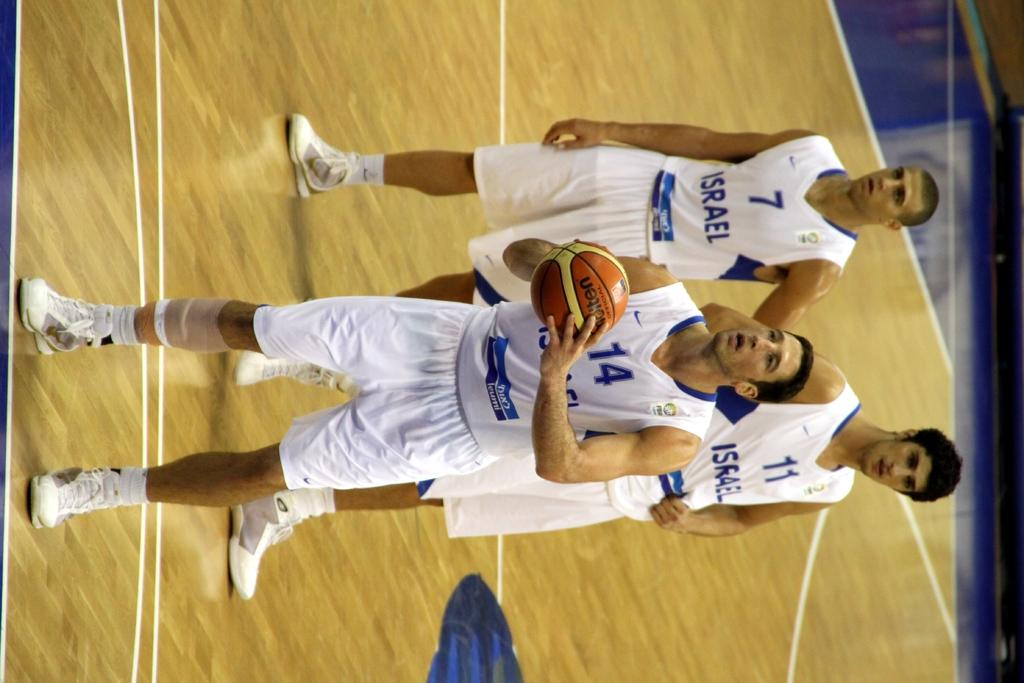<image>
Provide a brief description of the given image. Basketball player wearing number 14 shooting the basketball. 